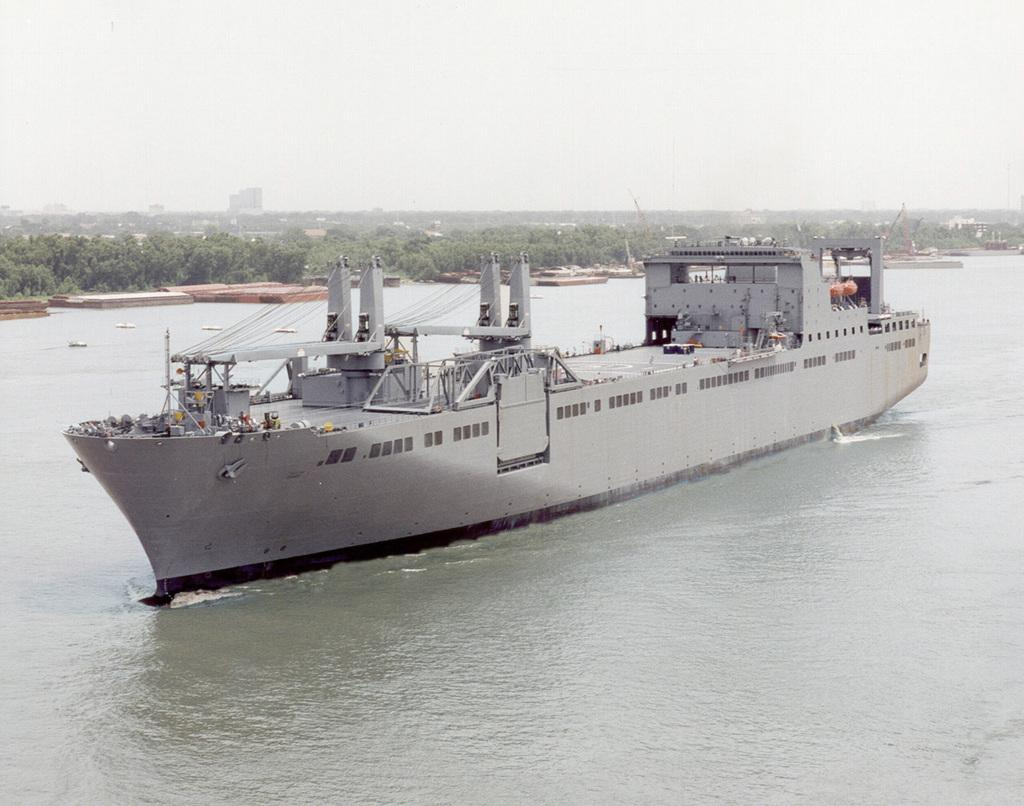What is the main subject in the center of the image? There is a ship in the center of the image. What can be seen in the background of the image? There are trees, buildings, and poles in the background of the image. What is present at the bottom of the image? There is water at the bottom of the image. What is visible at the top of the image? There is sky at the top of the image. Can you see any cobwebs on the ship in the image? There is no mention of cobwebs in the image, so we cannot determine if they are present or not. 